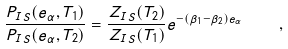<formula> <loc_0><loc_0><loc_500><loc_500>\frac { P _ { I S } ( e _ { \alpha } , T _ { 1 } ) } { P _ { I S } ( e _ { \alpha } , T _ { 2 } ) } = \frac { Z _ { I S } ( T _ { 2 } ) } { Z _ { I S } ( T _ { 1 } ) } e ^ { - ( \beta _ { 1 } - \beta _ { 2 } ) e _ { \alpha } } \, \quad ,</formula> 